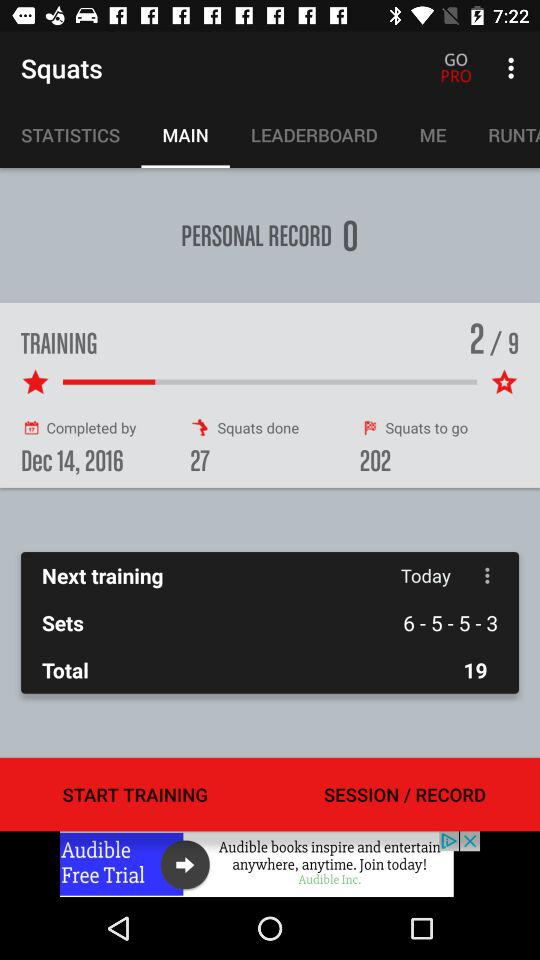What is the personal record? The personal record is 0. 